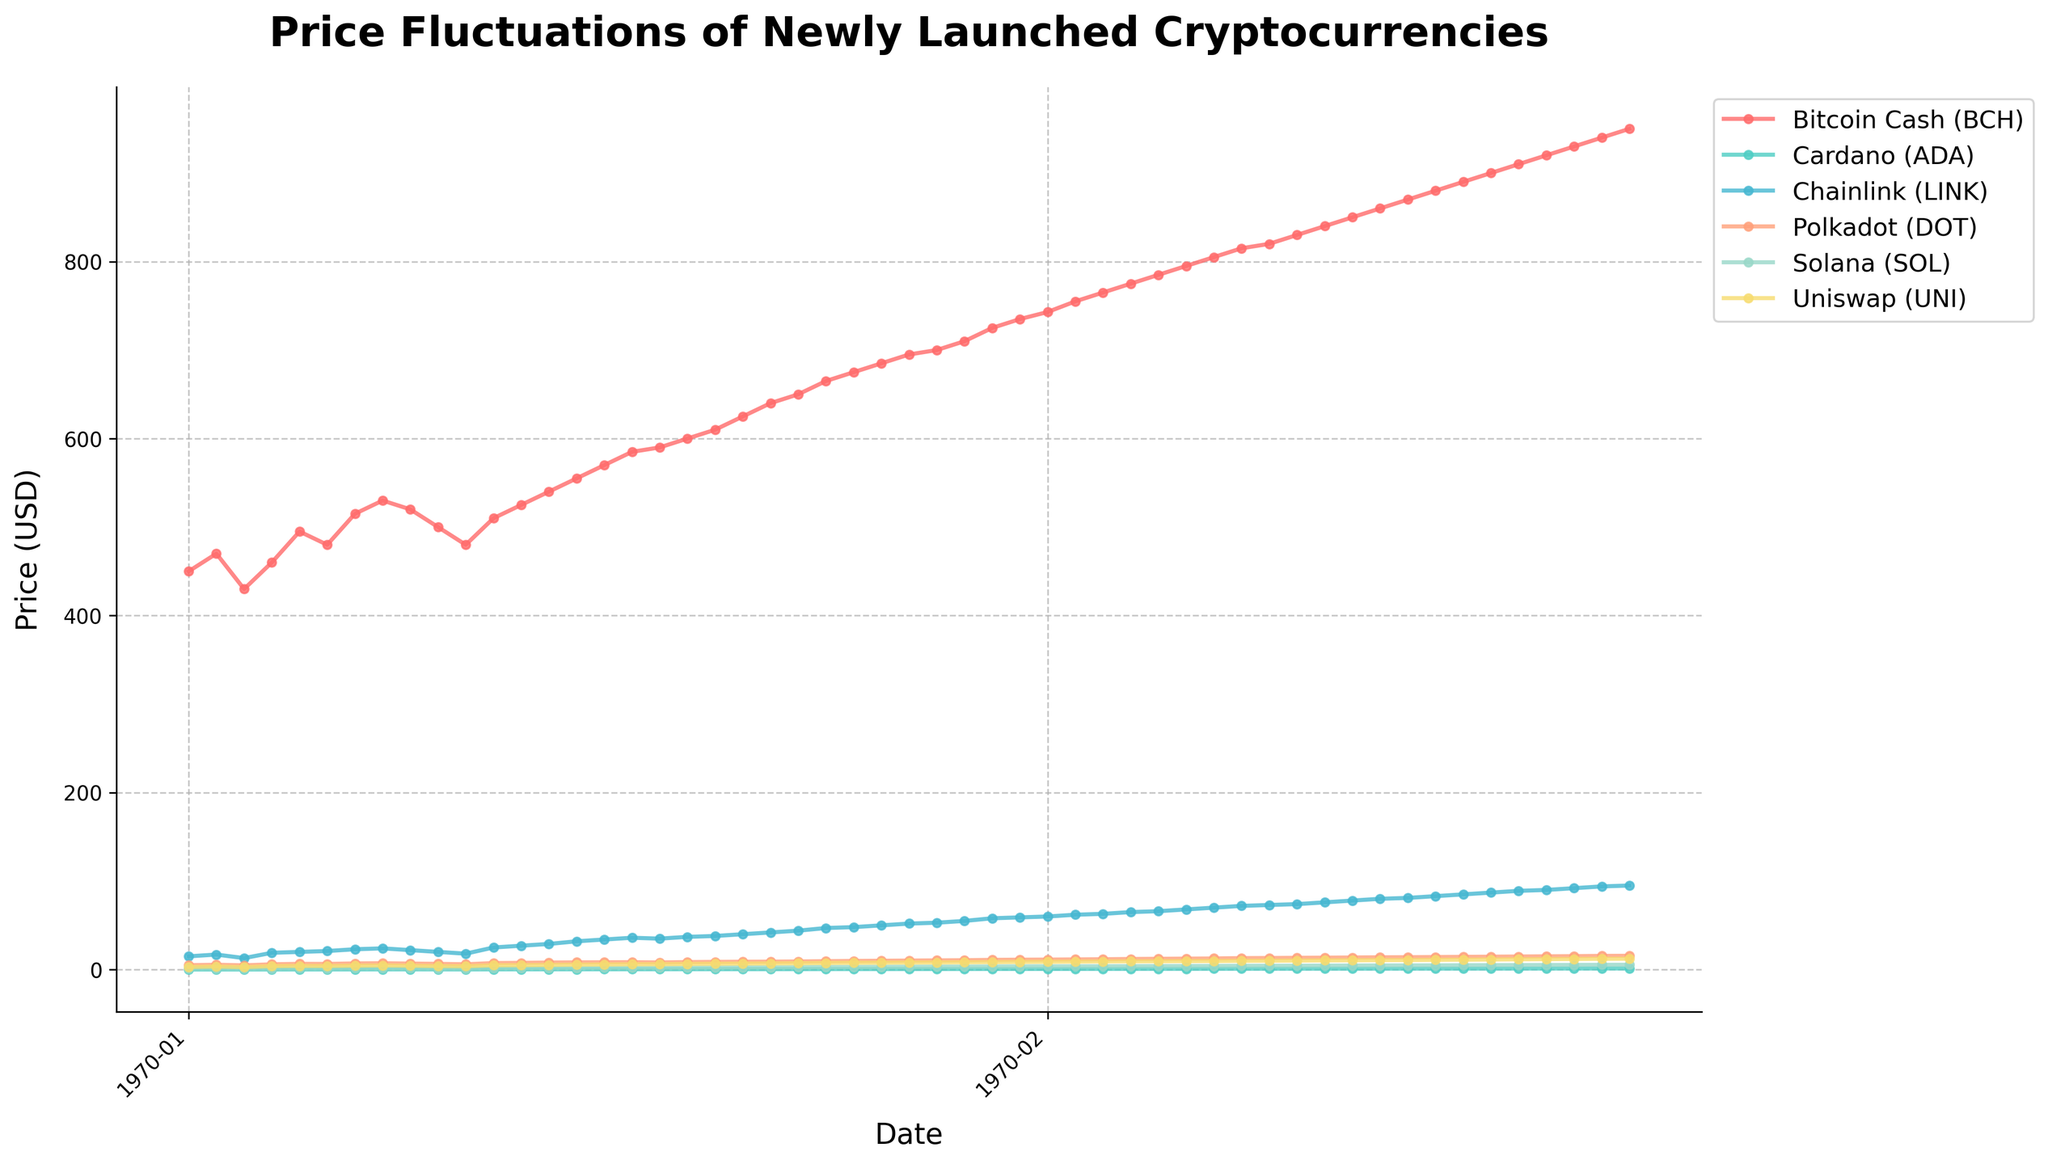what is the date range covered in this figure? The x-axis of the plot is labeled with dates, ranging from 2022-01-01 to 2022-12-31. By looking at the first and last tick on the x-axis, we can determine the date range.
Answer: 2022-01-01 to 2022-12-31 Which cryptocurrency had the highest price by the end of 2022? To find the highest price, we need to look at the last data point for each cryptocurrency. From the labels, the one with the highest final value needs to be identified.
Answer: Bitcoin Cash (BCH) What's the price difference for Solana (SOL) between January and December 2022? Check the initial and final price points for Solana (SOL) on the y-axis. In January, the price was 1.2, and in December, it was 5.45. Subtract the January price from the December price.
Answer: 4.25 Which date had the highest recorded price for Chainlink (LINK) and what was the value? Look for the peak of Chainlink (LINK) line and find the corresponding date and value. The highest value for Chainlink is found at the date where it reaches its peak.
Answer: 80 on 2022-10-29 Which cryptocurrencies showed a price increase of more than 2x from January to December 2022? For each cryptocurrency, compare the prices from January to December, and check whether the December price is more than twice the January price. Cardano (ADA) started at 0.12 and ended at 1.3, showing greater than 2x increase. Likewise, Solana (SOL) started at 1.2 and ended at 5.45, which is also more than twice. Similar calculations show such multipliers.
Answer: Cardano (ADA) and Solana (SOL) On which dates did Polkadot (DOT) and Uniswap (UNI) cross each other's price lines? Look for intersections of the lines representing Polkadot (DOT) and Uniswap (UNI). If they intersect, mark the dates where this happens by following their trajectories.
Answer: 2022-10-15 Which cryptocurrency had the most volatile price in the first quarter of 2022? Identify the cryptocurrency with the largest fluctuations (difference between maximum and minimum values) from January to March. Calculate the range of prices for each cryptocurrency over these dates, and the one with the largest range in these months is the most volatile.
Answer: Bitcoin Cash (BCH) What was the total price increase for Uniswap (UNI) over the year 2022? Find the initial and final prices of Uniswap (UNI). Initial price: 3 on January 1, Final price: 12.3 on December 31. Subtract the initial price from the final price to get the total increase.
Answer: 9.3 During which month did Cardano (ADA) see the steepest price increase? Look for the segment of the Cardano (ADA) line with the highest positive slope. Calculate the monthly differences to identify the month with the steepest price increase.
Answer: April Calculate the average price of Chainlink (LINK) in the second half of 2022. Total the prices of Chainlink (LINK) from July to December and divide by the number of data points (26 weeks starting from July 2). Sum is 1548, divide by 26.
Answer: 59.5 